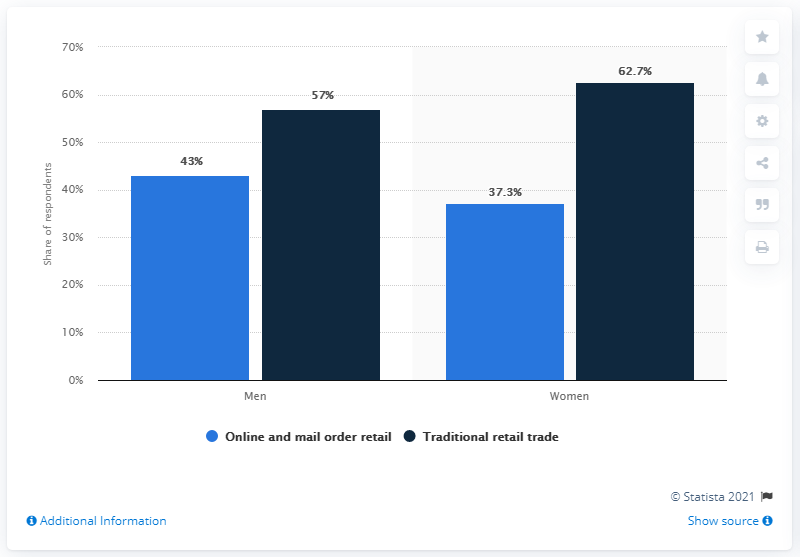Point out several critical features in this image. According to a survey, 37.3% of women reported that they prefer to shop online or via mail order. 